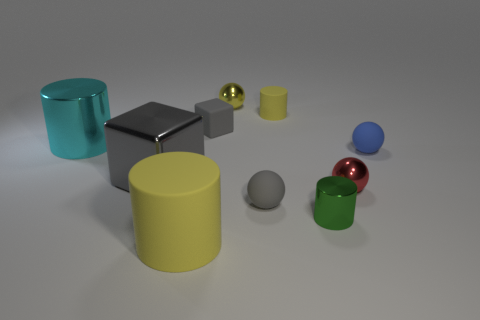Are there any other things that have the same color as the metal block?
Give a very brief answer. Yes. There is a metal ball that is in front of the large object that is left of the big metallic thing that is in front of the tiny blue object; how big is it?
Provide a short and direct response. Small. What size is the object that is left of the yellow shiny thing and behind the cyan metallic cylinder?
Ensure brevity in your answer.  Small. How many things are small matte spheres behind the small gray matte sphere or tiny red objects that are on the right side of the small gray rubber ball?
Offer a terse response. 2. Do the cylinder in front of the green cylinder and the large cyan cylinder have the same material?
Provide a succinct answer. No. The cylinder that is both behind the large gray shiny thing and to the left of the yellow metallic sphere is made of what material?
Make the answer very short. Metal. There is a small matte ball that is on the left side of the yellow cylinder behind the small blue matte ball; what color is it?
Keep it short and to the point. Gray. There is a green thing that is the same shape as the tiny yellow matte object; what is it made of?
Ensure brevity in your answer.  Metal. There is a small rubber thing that is on the right side of the yellow cylinder that is right of the small gray thing behind the large shiny block; what color is it?
Provide a short and direct response. Blue. What number of objects are either small green metallic cylinders or blue matte spheres?
Give a very brief answer. 2. 